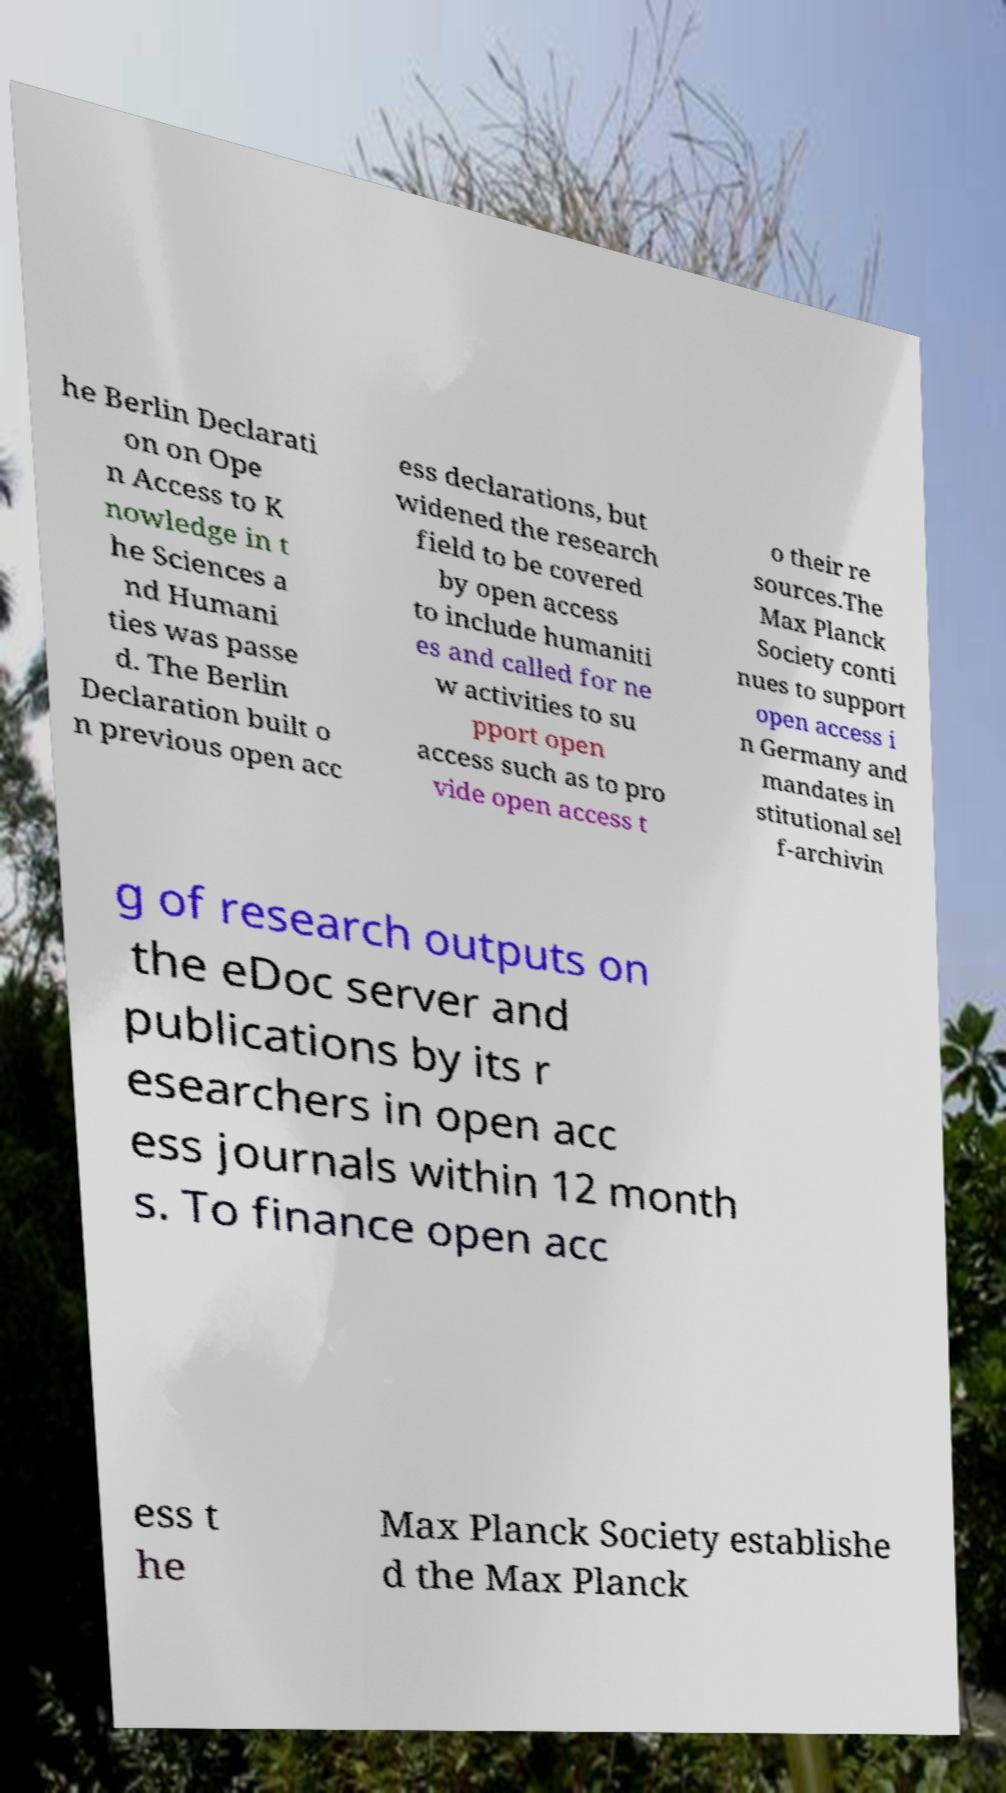Could you assist in decoding the text presented in this image and type it out clearly? he Berlin Declarati on on Ope n Access to K nowledge in t he Sciences a nd Humani ties was passe d. The Berlin Declaration built o n previous open acc ess declarations, but widened the research field to be covered by open access to include humaniti es and called for ne w activities to su pport open access such as to pro vide open access t o their re sources.The Max Planck Society conti nues to support open access i n Germany and mandates in stitutional sel f-archivin g of research outputs on the eDoc server and publications by its r esearchers in open acc ess journals within 12 month s. To finance open acc ess t he Max Planck Society establishe d the Max Planck 